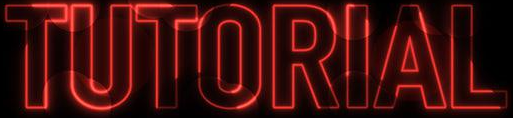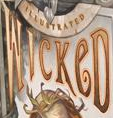Transcribe the words shown in these images in order, separated by a semicolon. TUTORIAL; WICKeD 